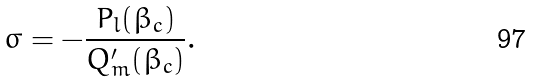<formula> <loc_0><loc_0><loc_500><loc_500>\sigma = - \frac { P _ { l } ( \beta _ { c } ) } { Q ^ { \prime } _ { m } ( \beta _ { c } ) } .</formula> 